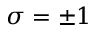Convert formula to latex. <formula><loc_0><loc_0><loc_500><loc_500>\sigma = \pm 1</formula> 